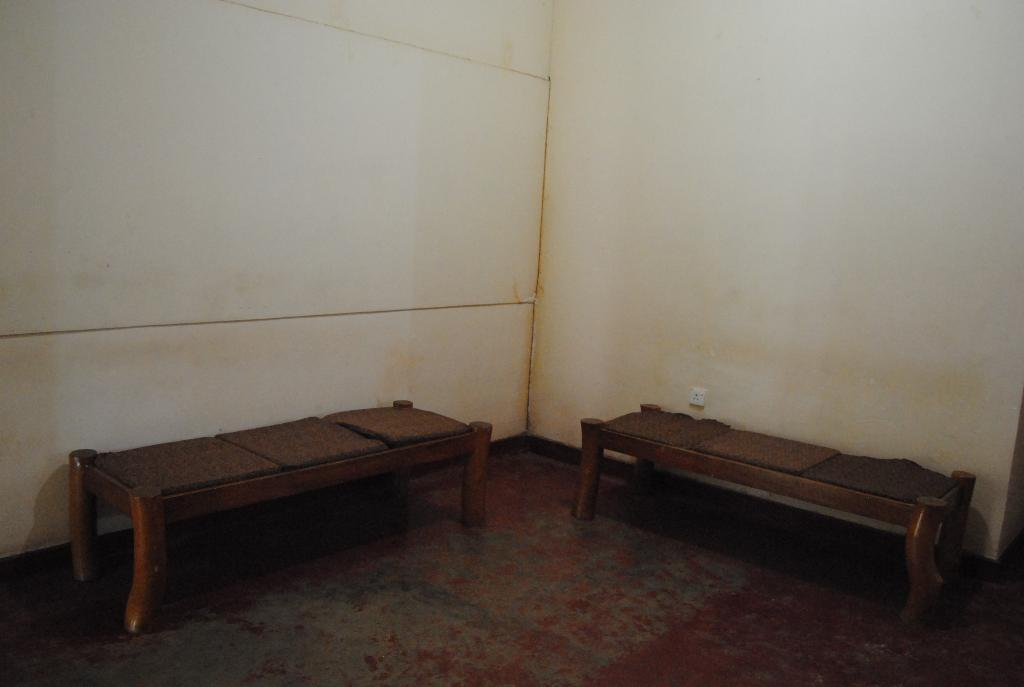How many benches can be seen in the image? There are two benches in the image. What other object is present in the image? There is a power socket in the image. What can be seen surrounding the benches and power socket? The walls are visible in the image. What type of jeans is the secretary wearing in the image? There is no secretary or jeans present in the image. 